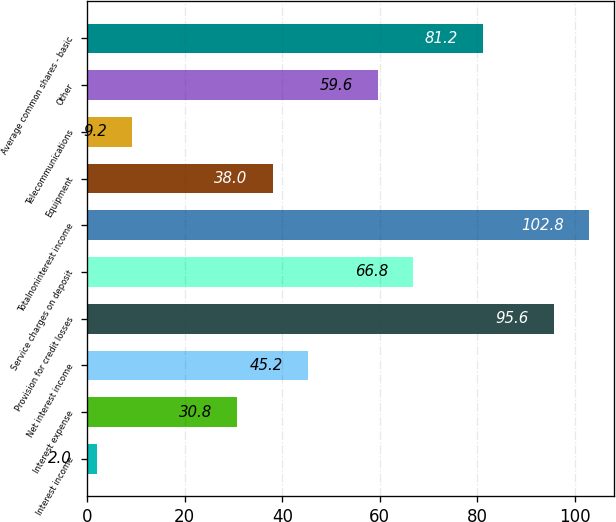Convert chart. <chart><loc_0><loc_0><loc_500><loc_500><bar_chart><fcel>Interest income<fcel>Interest expense<fcel>Net interest income<fcel>Provision for credit losses<fcel>Service charges on deposit<fcel>Totalnoninterest income<fcel>Equipment<fcel>Telecommunications<fcel>Other<fcel>Average common shares - basic<nl><fcel>2<fcel>30.8<fcel>45.2<fcel>95.6<fcel>66.8<fcel>102.8<fcel>38<fcel>9.2<fcel>59.6<fcel>81.2<nl></chart> 